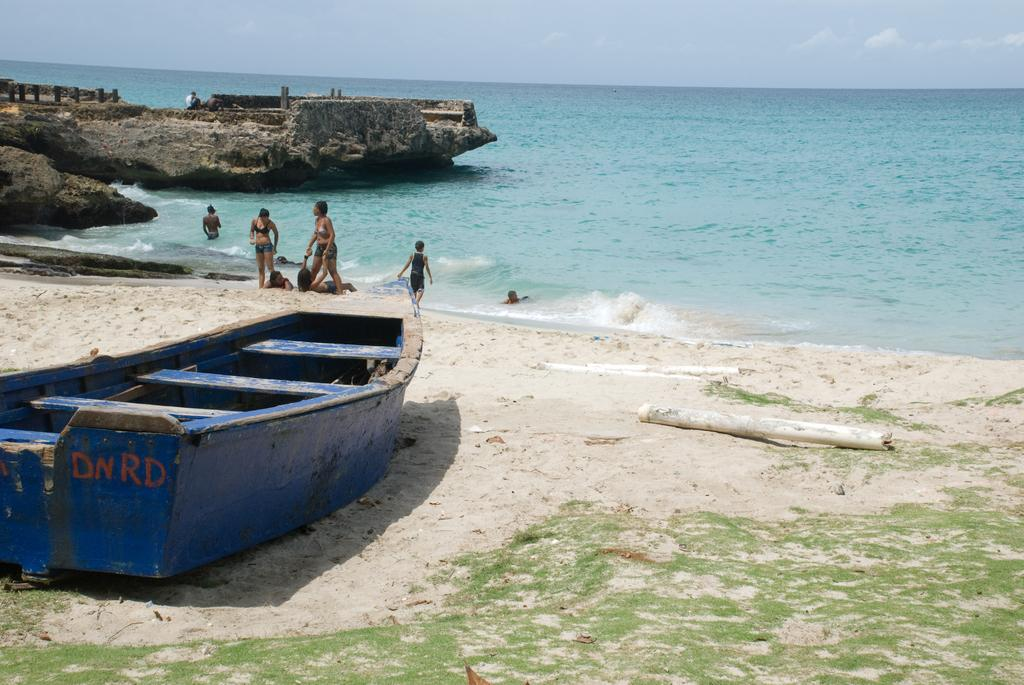What type of vehicle is located on the beach side in the image? There is a boat on the beach side in the image. Can you describe the people in the image? There are people in the image, but their specific actions or appearances are not mentioned in the provided facts. What body of water is visible in the image? There is an ocean in the image. What geological feature can be seen in the image? There is a rock in the image. What is the condition of the sky in the image? The sky is clear in the backdrop. What type of soda is being served to the wren in the image? There is no soda or wren present in the image. How does the rock express disgust in the image? Rocks do not have the ability to express emotions like disgust, and there is no indication of any emotion being expressed in the image. 